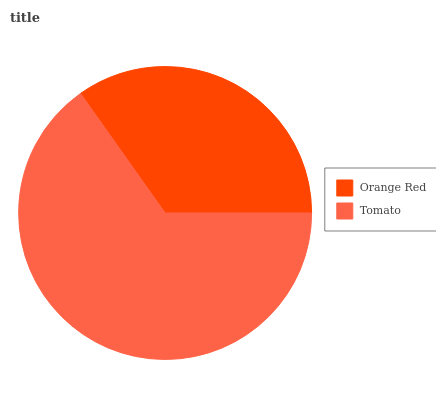Is Orange Red the minimum?
Answer yes or no. Yes. Is Tomato the maximum?
Answer yes or no. Yes. Is Tomato the minimum?
Answer yes or no. No. Is Tomato greater than Orange Red?
Answer yes or no. Yes. Is Orange Red less than Tomato?
Answer yes or no. Yes. Is Orange Red greater than Tomato?
Answer yes or no. No. Is Tomato less than Orange Red?
Answer yes or no. No. Is Tomato the high median?
Answer yes or no. Yes. Is Orange Red the low median?
Answer yes or no. Yes. Is Orange Red the high median?
Answer yes or no. No. Is Tomato the low median?
Answer yes or no. No. 